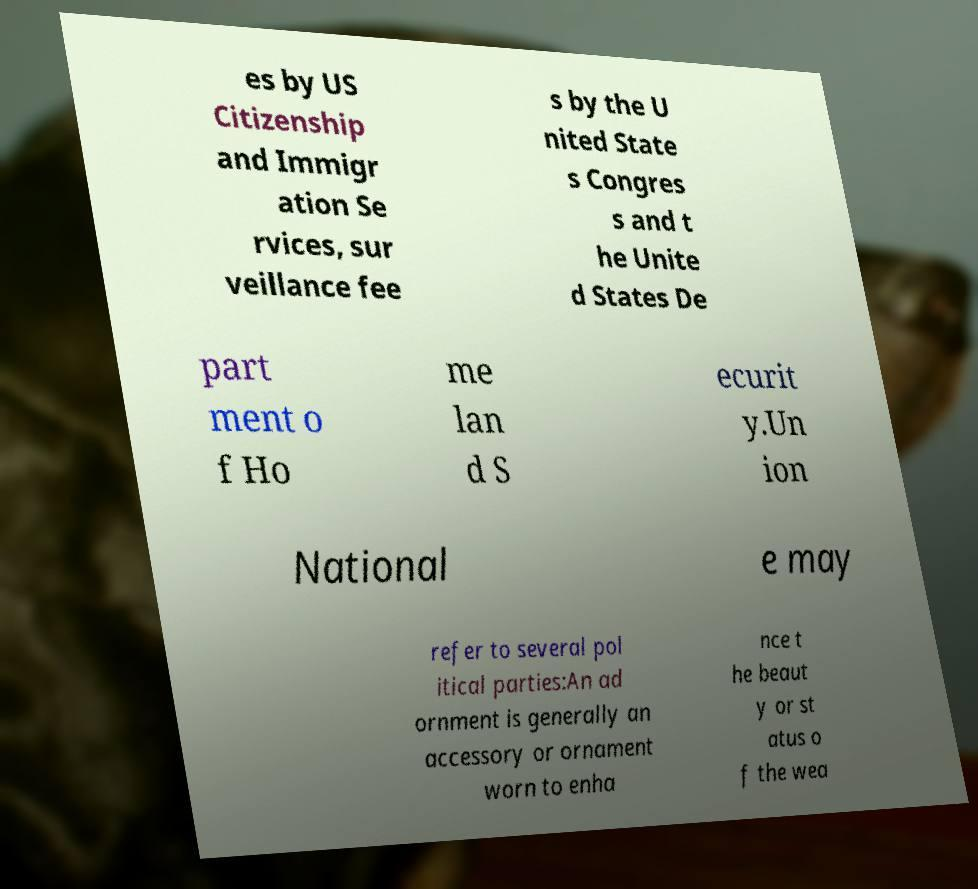Can you read and provide the text displayed in the image?This photo seems to have some interesting text. Can you extract and type it out for me? es by US Citizenship and Immigr ation Se rvices, sur veillance fee s by the U nited State s Congres s and t he Unite d States De part ment o f Ho me lan d S ecurit y.Un ion National e may refer to several pol itical parties:An ad ornment is generally an accessory or ornament worn to enha nce t he beaut y or st atus o f the wea 